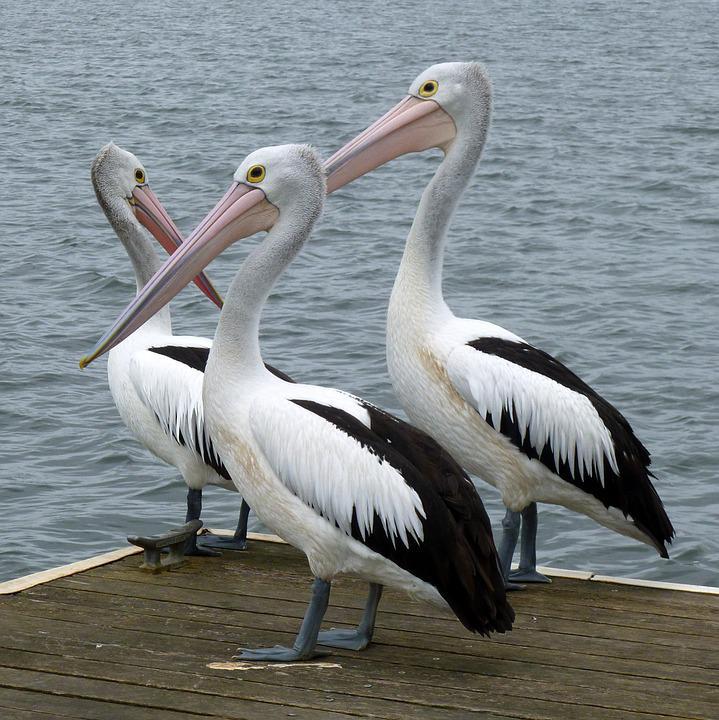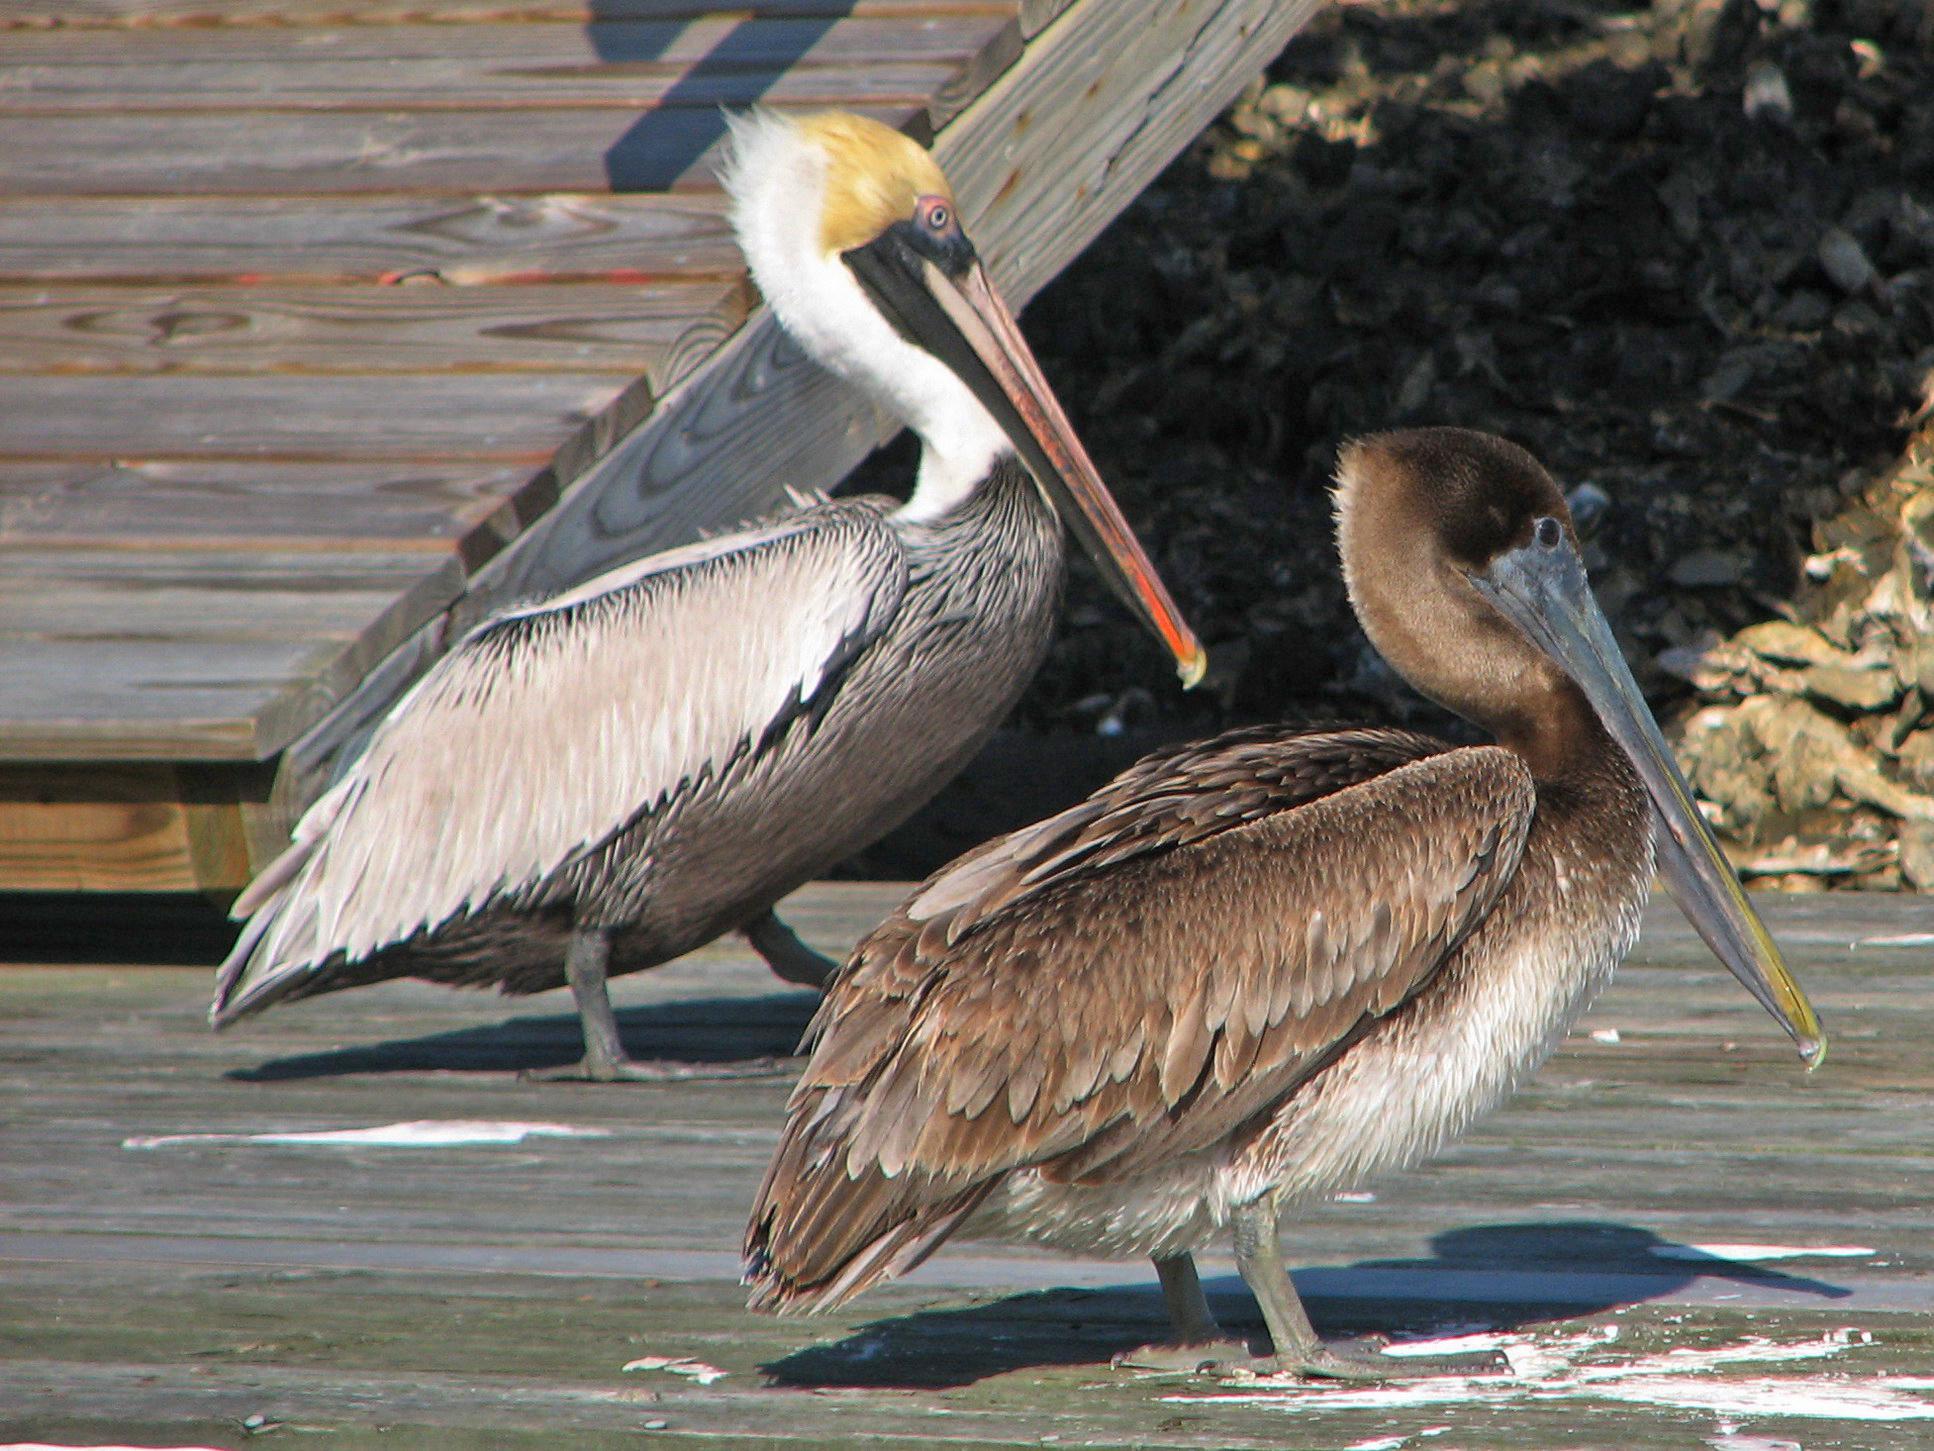The first image is the image on the left, the second image is the image on the right. Assess this claim about the two images: "There are no more than three pelicans". Correct or not? Answer yes or no. No. The first image is the image on the left, the second image is the image on the right. Examine the images to the left and right. Is the description "One image shows three pelicans on the edge of a pier." accurate? Answer yes or no. Yes. 